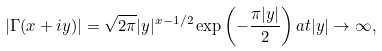<formula> <loc_0><loc_0><loc_500><loc_500>| \Gamma ( x + i y ) | = \sqrt { 2 \pi } | y | ^ { x - 1 / 2 } \exp \left ( - \frac { \pi | y | } { 2 } \right ) a t | y | \rightarrow \infty ,</formula> 